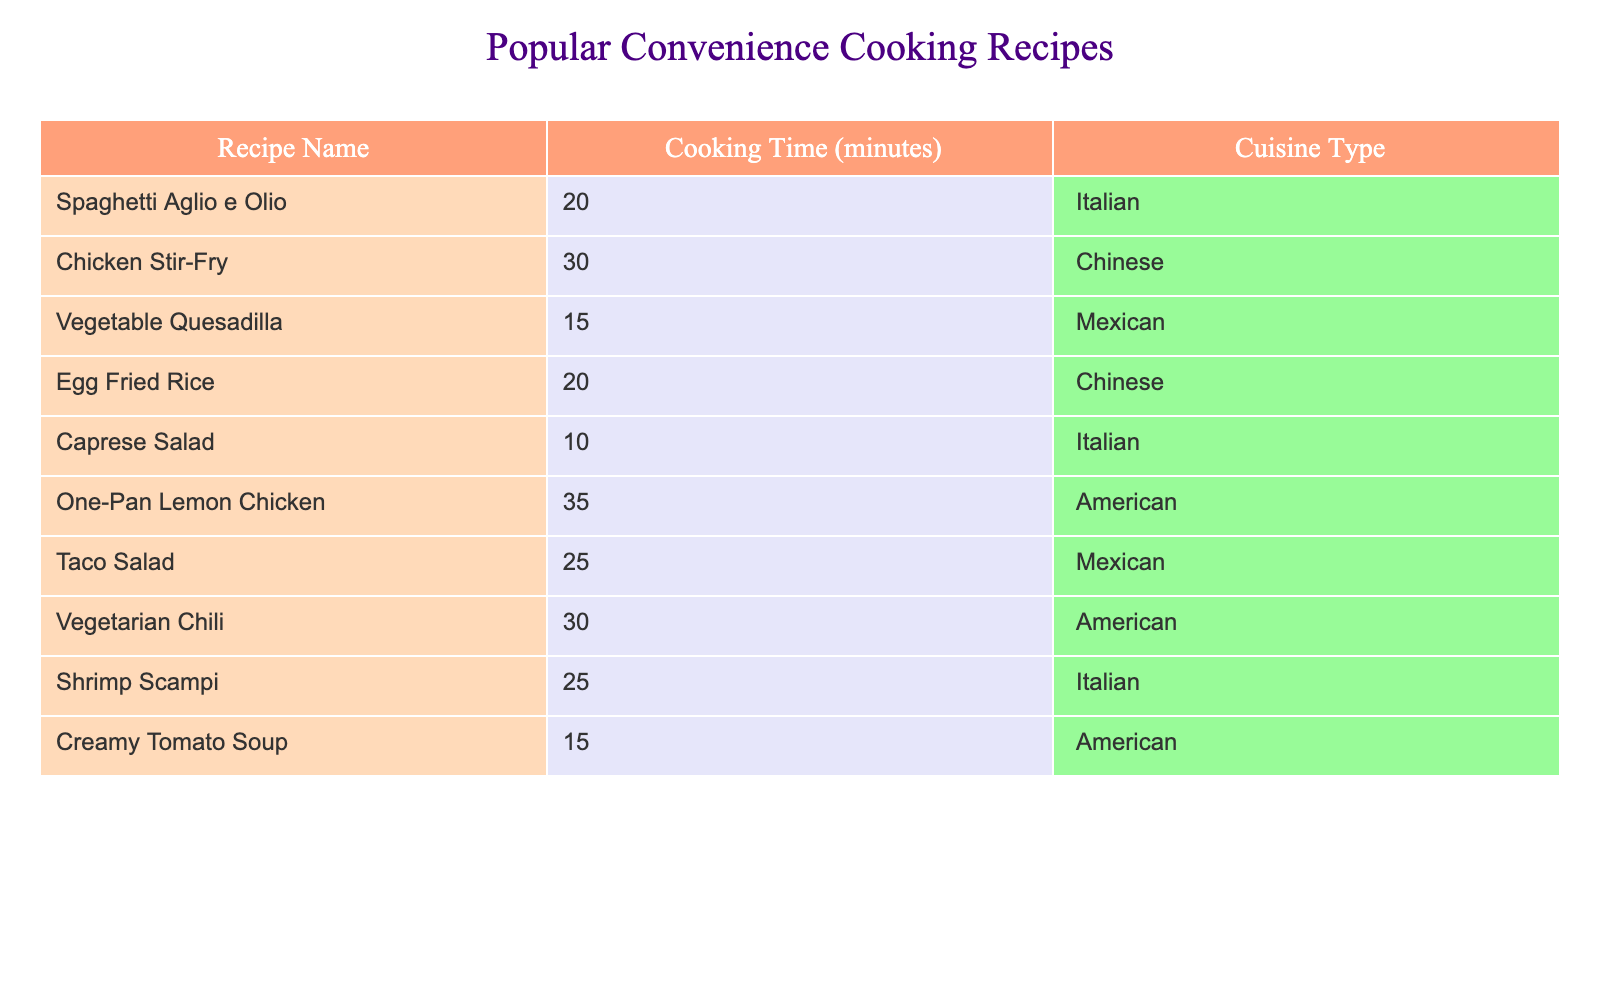What is the cooking time for the Vegetable Quesadilla? The table indicates that the cooking time listed next to Vegetable Quesadilla is 15 minutes.
Answer: 15 minutes Which recipe has the longest cooking time? From the table, One-Pan Lemon Chicken has the longest cooking time at 35 minutes, as it is greater than all the other recipes listed.
Answer: 35 minutes How many recipes take 30 minutes to cook? The table lists two recipes with a cooking time of 30 minutes: Chicken Stir-Fry and Vegetarian Chili. Therefore, there are 2 recipes.
Answer: 2 recipes Is there a recipe that takes exactly 10 minutes to cook? Referring to the table, Caprese Salad is the only recipe that has a cooking time of exactly 10 minutes.
Answer: Yes What is the average cooking time of all the recipes listed? Summing the cooking times from the table gives: 20 + 30 + 15 + 20 + 10 + 35 + 25 + 30 + 25 + 15 =  225 minutes. There are 10 recipes, so the average is calculated as 225/10 = 22.5 minutes.
Answer: 22.5 minutes How many Italian recipes are listed that take less than 30 minutes? The table shows Spaghetti Aglio e Olio (20 minutes) and Shrimp Scampi (25 minutes) as the only Italian recipes that take less than 30 minutes. Thus, there are 2 Italian recipes.
Answer: 2 Italian recipes Which cuisine type has the lowest total cooking time when combining the recipes? The cooking times for each cuisine type are: Italian (20 + 25 + 10 = 55), Chinese (30 + 20 = 50), Mexican (15 + 25 = 40), and American (35 + 30 + 15 = 80). The lowest total is for Mexican cuisine with a cooking time of 40 minutes.
Answer: Mexican cuisine (40 minutes) Are there any American recipes that take less than 20 minutes to cook? Reviewing the table, there are no American recipes listed that take less than 20 minutes; Creamy Tomato Soup is the shortest at 15 minutes, but it is not American.
Answer: No 